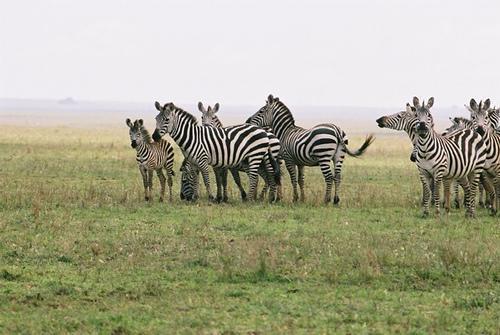How many baby zebras are there?
Give a very brief answer. 1. How many zebras are bunched to the left?
Give a very brief answer. 4. How many vehicles are there?
Give a very brief answer. 0. How many zebras are in the picture?
Give a very brief answer. 4. 